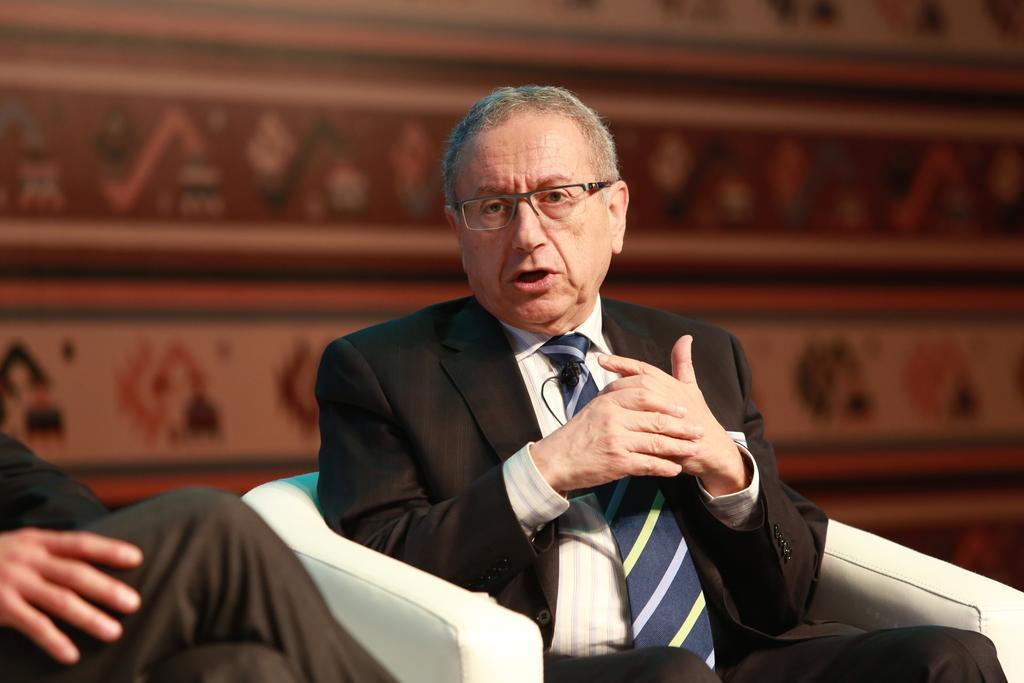Could you give a brief overview of what you see in this image? In this image in front there are two people sitting on the chairs. Behind them there is a wall with the painting on it. 